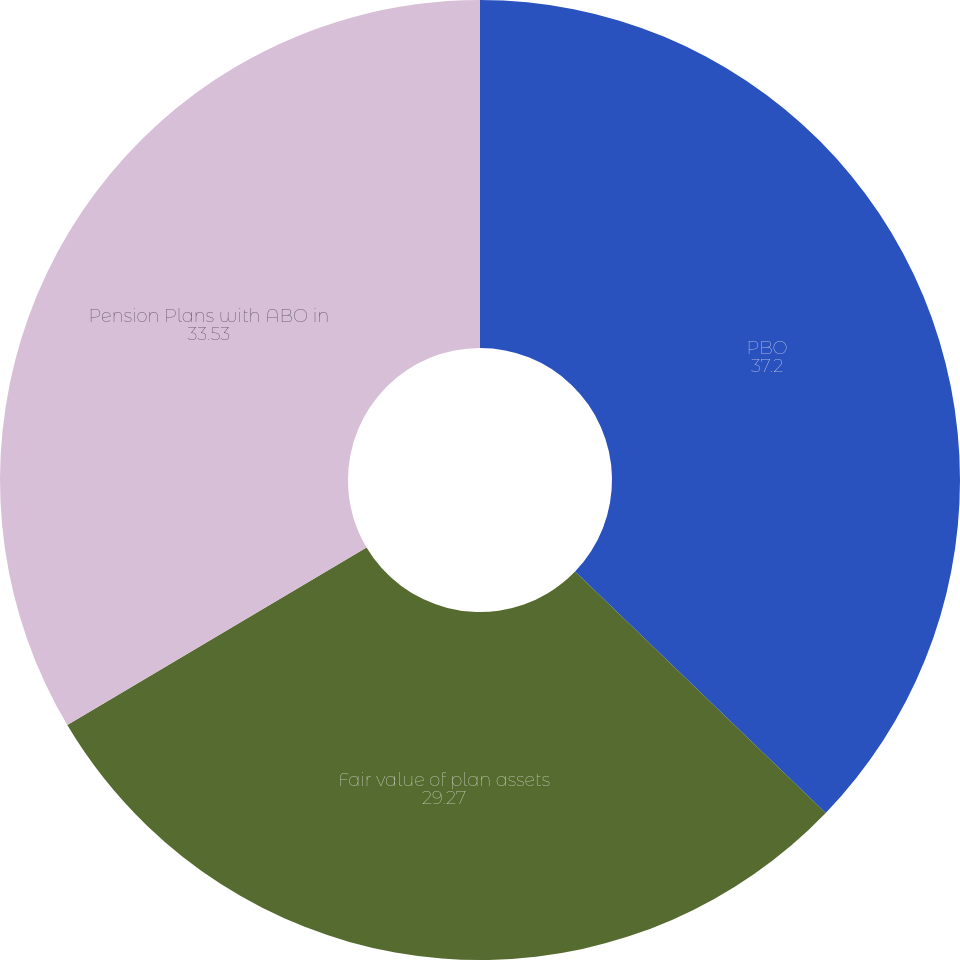<chart> <loc_0><loc_0><loc_500><loc_500><pie_chart><fcel>PBO<fcel>Fair value of plan assets<fcel>Pension Plans with ABO in<nl><fcel>37.2%<fcel>29.27%<fcel>33.53%<nl></chart> 